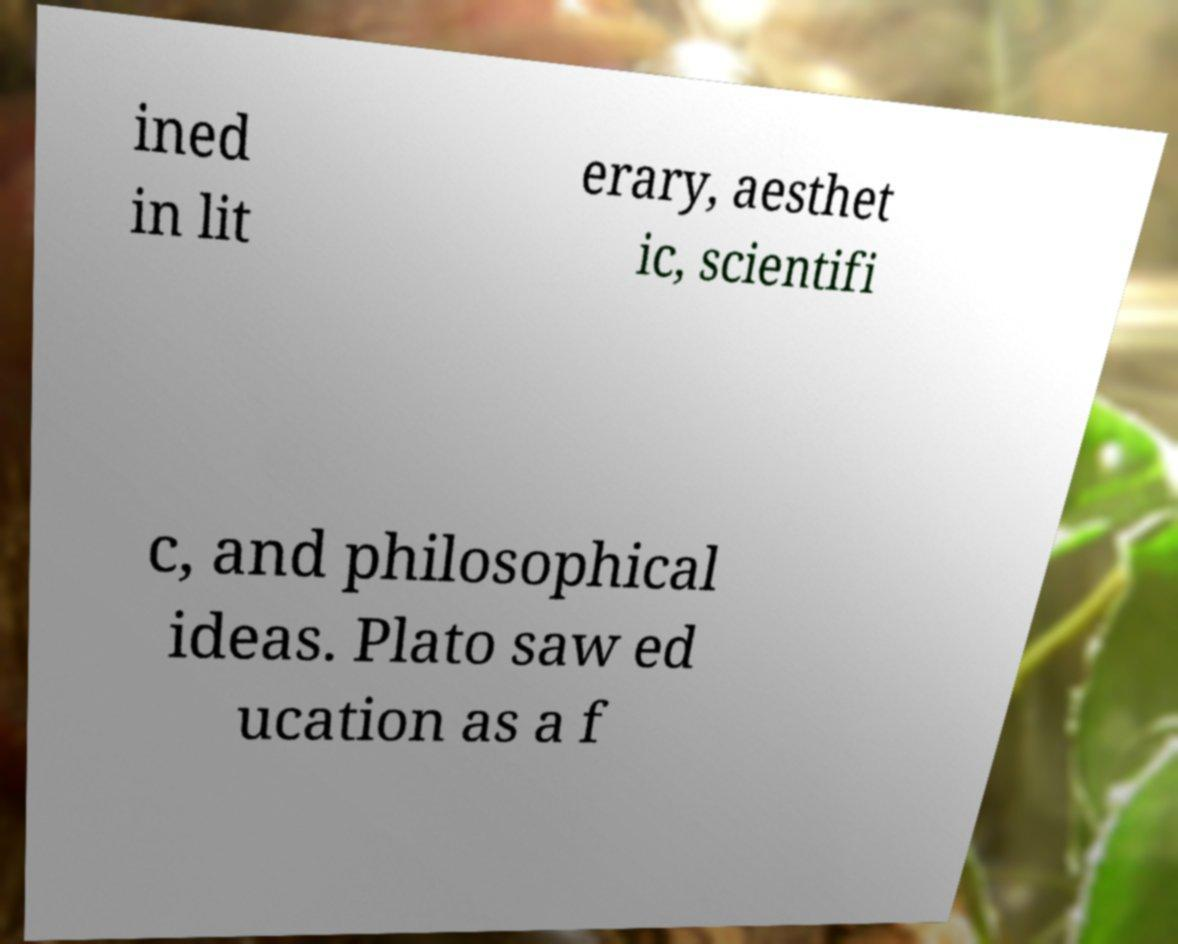Please read and relay the text visible in this image. What does it say? ined in lit erary, aesthet ic, scientifi c, and philosophical ideas. Plato saw ed ucation as a f 